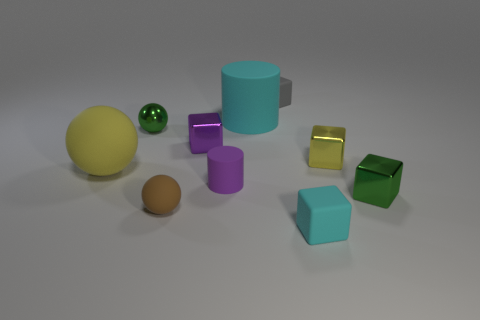Subtract all yellow cubes. How many cubes are left? 4 Subtract all tiny purple shiny cubes. How many cubes are left? 4 Subtract all purple spheres. Subtract all purple cubes. How many spheres are left? 3 Subtract all cylinders. How many objects are left? 8 Add 4 small purple cylinders. How many small purple cylinders are left? 5 Add 7 large metallic cylinders. How many large metallic cylinders exist? 7 Subtract 0 gray cylinders. How many objects are left? 10 Subtract all tiny green balls. Subtract all tiny green things. How many objects are left? 7 